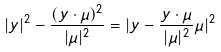Convert formula to latex. <formula><loc_0><loc_0><loc_500><loc_500>| y | ^ { 2 } - \frac { ( y \cdot \mu ) ^ { 2 } } { | \mu | ^ { 2 } } = | y - \frac { y \cdot \mu } { | \mu | ^ { 2 } } \mu | ^ { 2 }</formula> 